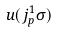<formula> <loc_0><loc_0><loc_500><loc_500>u ( j _ { p } ^ { 1 } \sigma )</formula> 